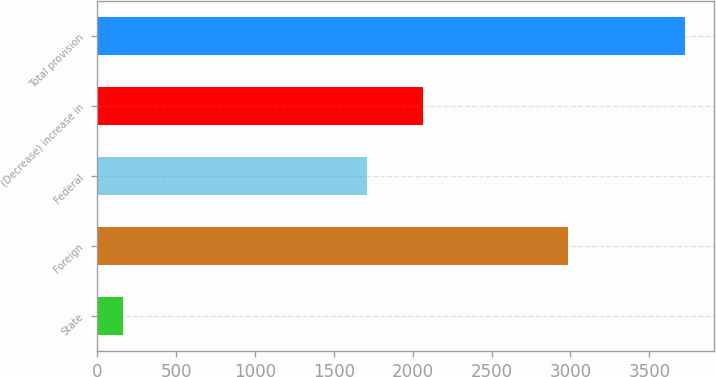Convert chart to OTSL. <chart><loc_0><loc_0><loc_500><loc_500><bar_chart><fcel>State<fcel>Foreign<fcel>Federal<fcel>(Decrease) increase in<fcel>Total provision<nl><fcel>165<fcel>2984<fcel>1709<fcel>2065<fcel>3725<nl></chart> 